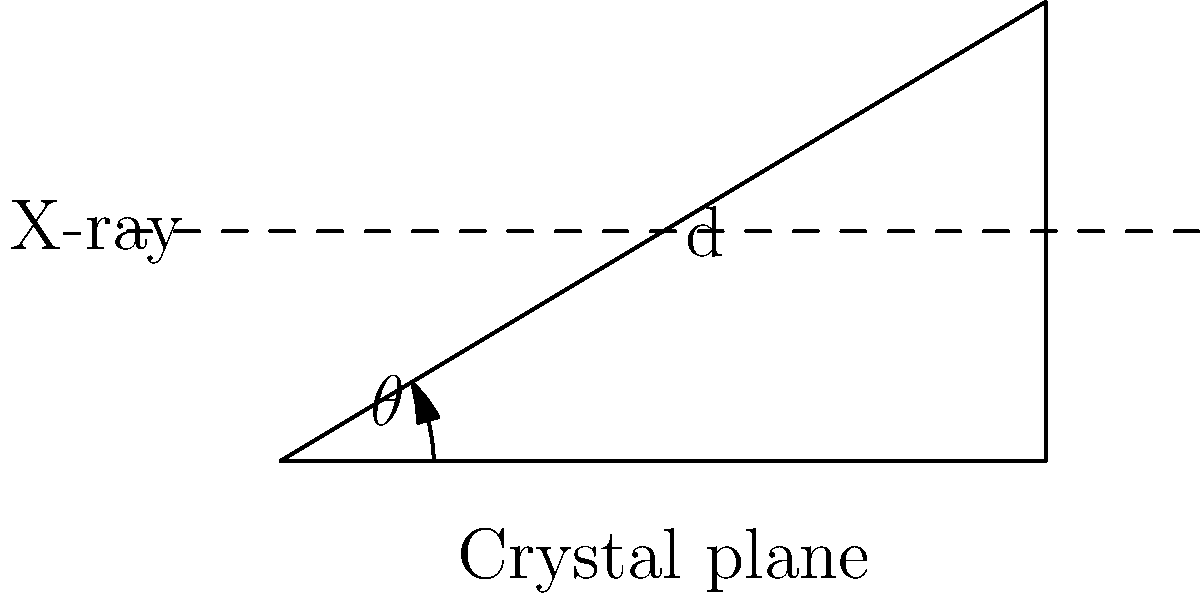In an X-ray diffraction experiment for protein crystallography, the distance between crystal planes (d) is 3.5 Å, and the wavelength of the X-ray used is 1.54 Å. Using Bragg's law, calculate the angle of incidence ($\theta$) for the first-order diffraction (n = 1). To solve this problem, we'll use Bragg's law and follow these steps:

1) Bragg's law is given by the equation:

   $$n\lambda = 2d\sin\theta$$

   Where:
   $n$ = order of diffraction (given as 1)
   $\lambda$ = wavelength of X-ray
   $d$ = distance between crystal planes
   $\theta$ = angle of incidence

2) We're given:
   $n = 1$
   $\lambda = 1.54$ Å
   $d = 3.5$ Å

3) Substitute these values into Bragg's law:

   $$1 \cdot 1.54 = 2 \cdot 3.5 \cdot \sin\theta$$

4) Simplify:

   $$1.54 = 7 \cdot \sin\theta$$

5) Divide both sides by 7:

   $$\frac{1.54}{7} = \sin\theta$$

6) Take the inverse sine (arcsin) of both sides:

   $$\theta = \arcsin(\frac{1.54}{7})$$

7) Calculate the result:

   $$\theta \approx 12.7°$$
Answer: $12.7°$ 